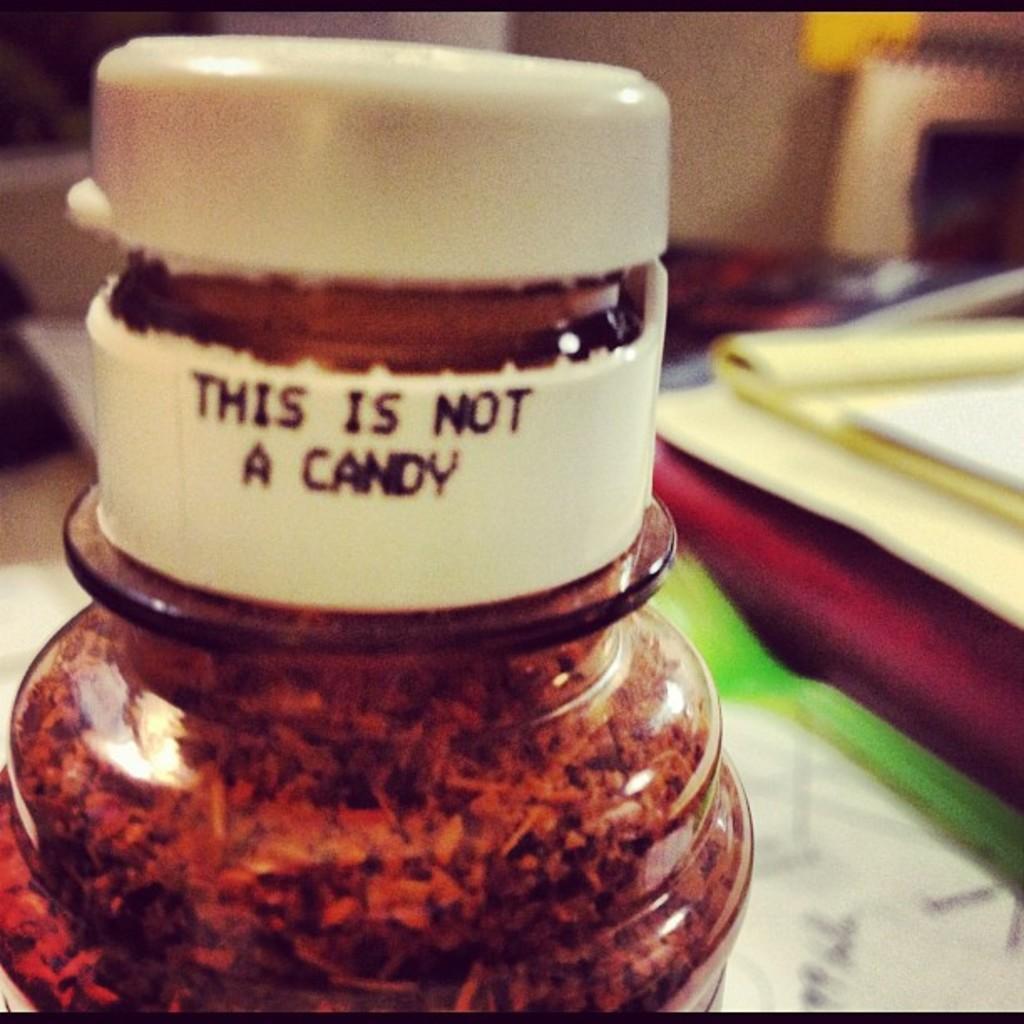Describe this image in one or two sentences. In the center of the image there is a bottle. On the right side of the image we can see papers and books. In the background we can see wall and book. 